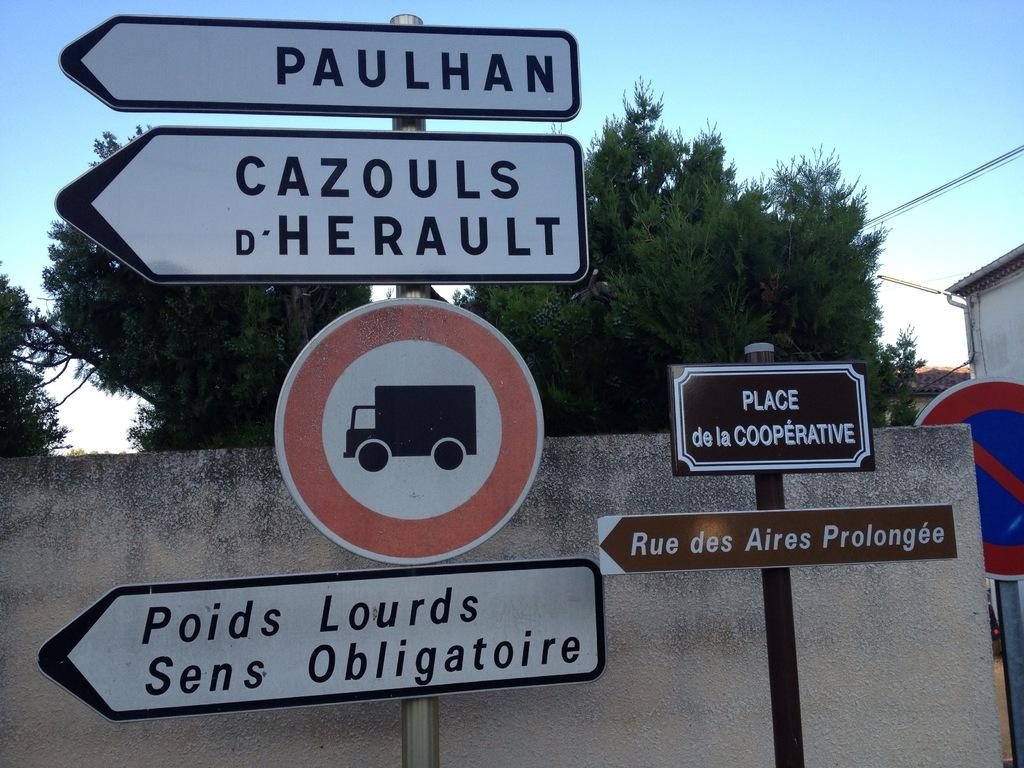What is the main feature of the image? The main feature of the image is poles with boards. What can be seen in the background of the image? In the background of the image, there are walls, trees, wires, and the sky. Can you describe the poles with boards in more detail? The poles with boards appear to be part of a structure or fence. Where is the turkey located in the image? There is no turkey present in the image. Can you tell me how many giraffes are visible in the image? There are no giraffes visible in the image. 